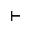<formula> <loc_0><loc_0><loc_500><loc_500>\vdash</formula> 